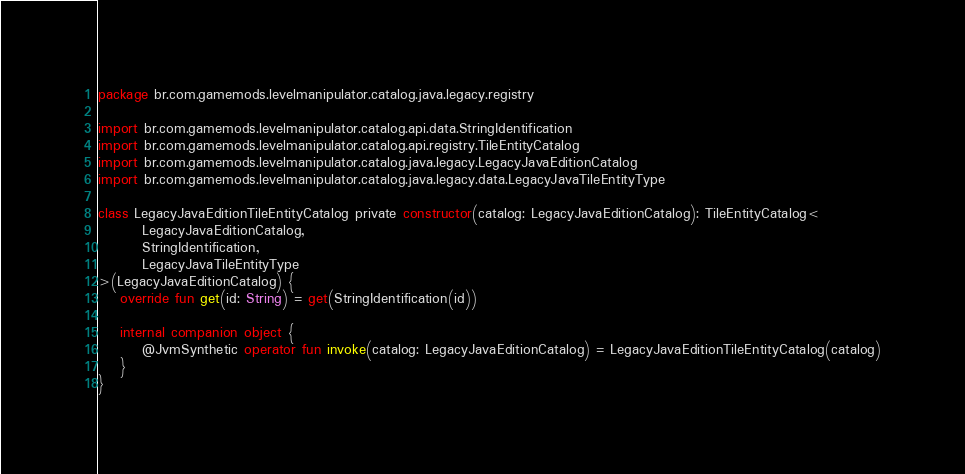Convert code to text. <code><loc_0><loc_0><loc_500><loc_500><_Kotlin_>package br.com.gamemods.levelmanipulator.catalog.java.legacy.registry

import br.com.gamemods.levelmanipulator.catalog.api.data.StringIdentification
import br.com.gamemods.levelmanipulator.catalog.api.registry.TileEntityCatalog
import br.com.gamemods.levelmanipulator.catalog.java.legacy.LegacyJavaEditionCatalog
import br.com.gamemods.levelmanipulator.catalog.java.legacy.data.LegacyJavaTileEntityType

class LegacyJavaEditionTileEntityCatalog private constructor(catalog: LegacyJavaEditionCatalog): TileEntityCatalog<
        LegacyJavaEditionCatalog,
        StringIdentification,
        LegacyJavaTileEntityType
>(LegacyJavaEditionCatalog) {
    override fun get(id: String) = get(StringIdentification(id))

    internal companion object {
        @JvmSynthetic operator fun invoke(catalog: LegacyJavaEditionCatalog) = LegacyJavaEditionTileEntityCatalog(catalog)
    }
}
</code> 